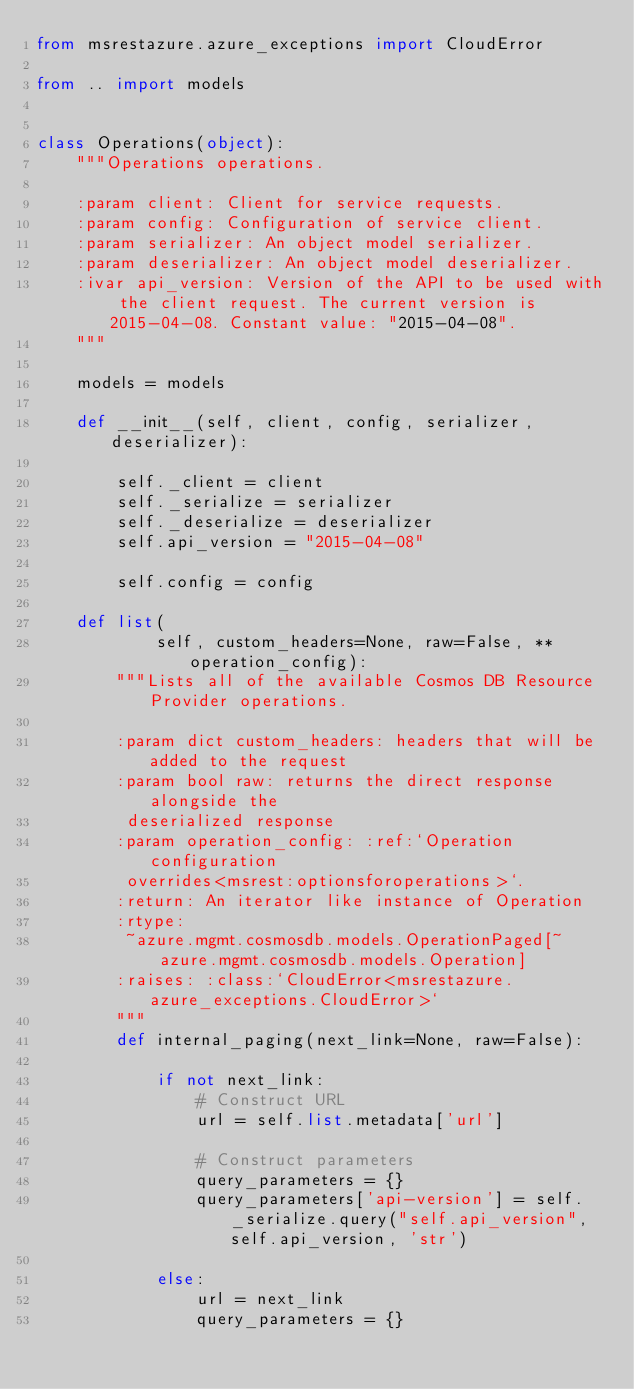Convert code to text. <code><loc_0><loc_0><loc_500><loc_500><_Python_>from msrestazure.azure_exceptions import CloudError

from .. import models


class Operations(object):
    """Operations operations.

    :param client: Client for service requests.
    :param config: Configuration of service client.
    :param serializer: An object model serializer.
    :param deserializer: An object model deserializer.
    :ivar api_version: Version of the API to be used with the client request. The current version is 2015-04-08. Constant value: "2015-04-08".
    """

    models = models

    def __init__(self, client, config, serializer, deserializer):

        self._client = client
        self._serialize = serializer
        self._deserialize = deserializer
        self.api_version = "2015-04-08"

        self.config = config

    def list(
            self, custom_headers=None, raw=False, **operation_config):
        """Lists all of the available Cosmos DB Resource Provider operations.

        :param dict custom_headers: headers that will be added to the request
        :param bool raw: returns the direct response alongside the
         deserialized response
        :param operation_config: :ref:`Operation configuration
         overrides<msrest:optionsforoperations>`.
        :return: An iterator like instance of Operation
        :rtype:
         ~azure.mgmt.cosmosdb.models.OperationPaged[~azure.mgmt.cosmosdb.models.Operation]
        :raises: :class:`CloudError<msrestazure.azure_exceptions.CloudError>`
        """
        def internal_paging(next_link=None, raw=False):

            if not next_link:
                # Construct URL
                url = self.list.metadata['url']

                # Construct parameters
                query_parameters = {}
                query_parameters['api-version'] = self._serialize.query("self.api_version", self.api_version, 'str')

            else:
                url = next_link
                query_parameters = {}
</code> 